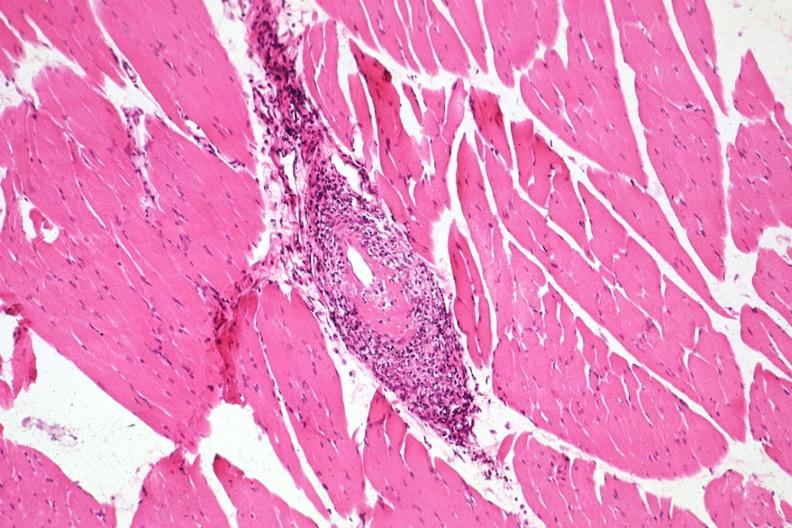what is present?
Answer the question using a single word or phrase. Soft tissue 